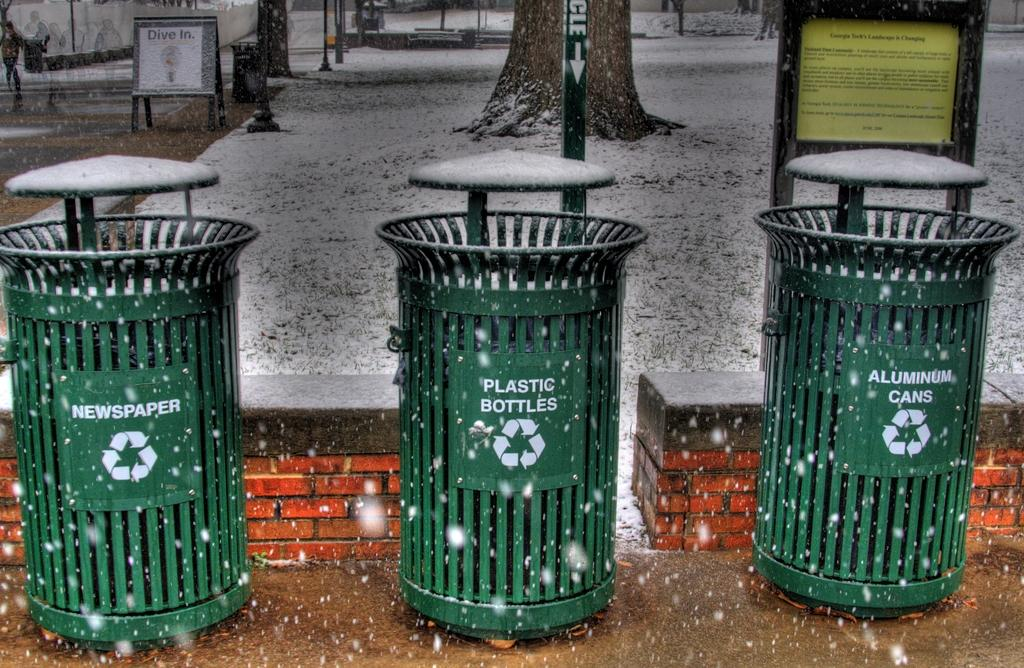<image>
Offer a succinct explanation of the picture presented. Three green trash cans are lined up for newspaper, plastic bottles, and cans. 